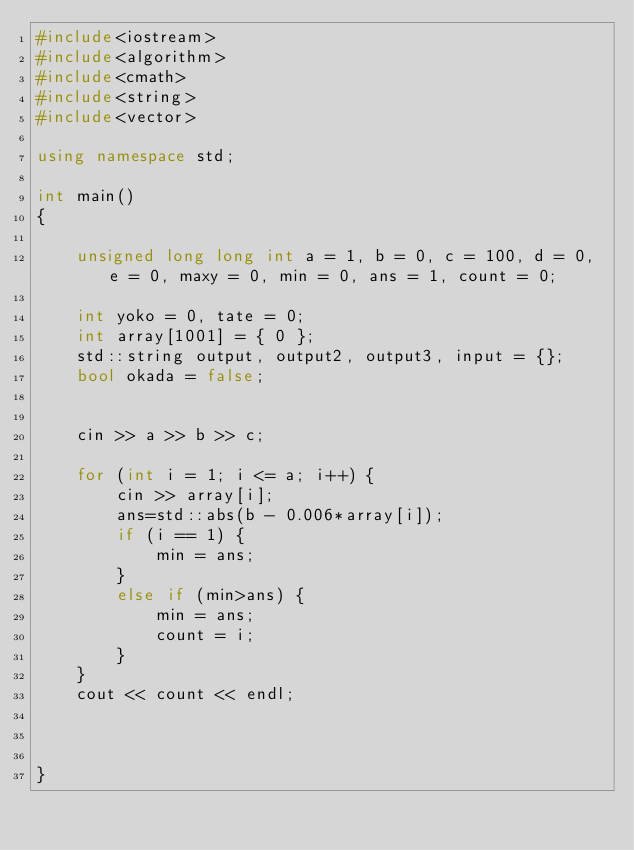Convert code to text. <code><loc_0><loc_0><loc_500><loc_500><_C++_>#include<iostream>
#include<algorithm>
#include<cmath>
#include<string>
#include<vector>

using namespace std;

int main()
{

	unsigned long long int a = 1, b = 0, c = 100, d = 0, e = 0, maxy = 0, min = 0, ans = 1, count = 0;

	int yoko = 0, tate = 0;
	int array[1001] = { 0 };
	std::string output, output2, output3, input = {};
	bool okada = false;


	cin >> a >> b >> c;
	
	for (int i = 1; i <= a; i++) {
		cin >> array[i];
		ans=std::abs(b - 0.006*array[i]);
		if (i == 1) {
			min = ans;
		}
		else if (min>ans) {
			min = ans;
			count = i;
		}
	}
	cout << count << endl;
	


}




</code> 